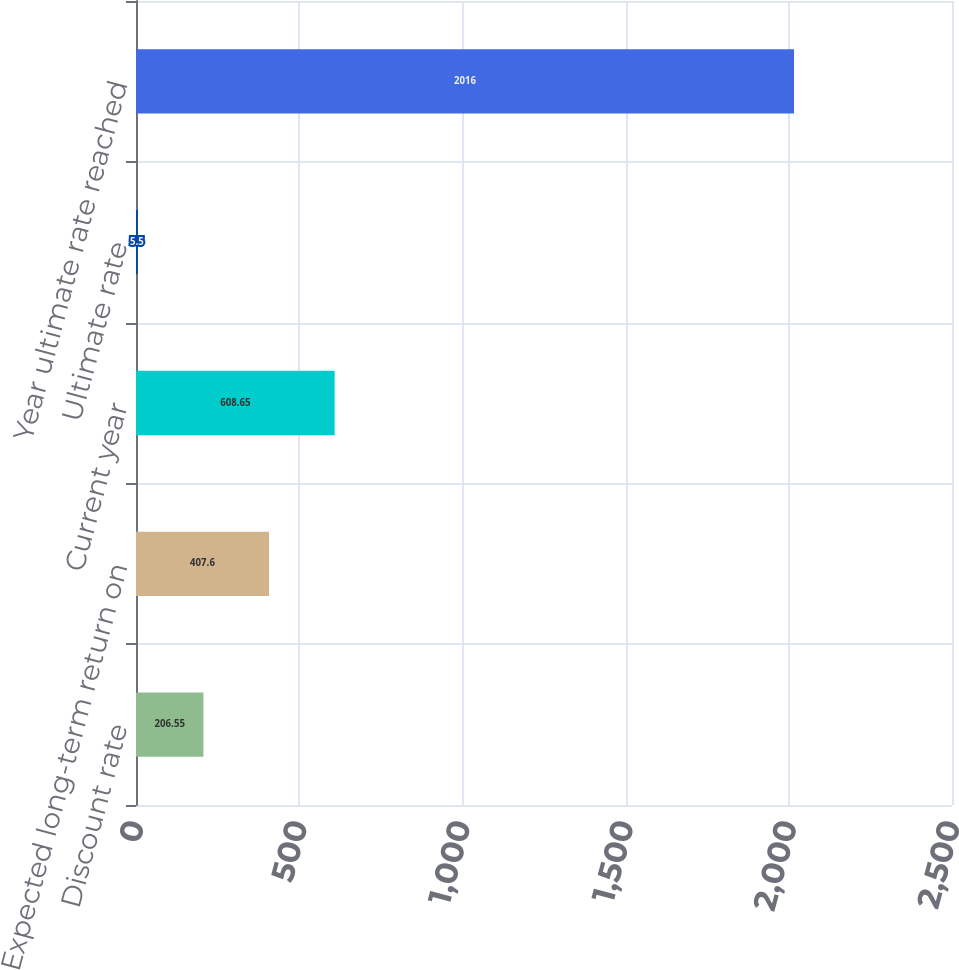Convert chart to OTSL. <chart><loc_0><loc_0><loc_500><loc_500><bar_chart><fcel>Discount rate<fcel>Expected long-term return on<fcel>Current year<fcel>Ultimate rate<fcel>Year ultimate rate reached<nl><fcel>206.55<fcel>407.6<fcel>608.65<fcel>5.5<fcel>2016<nl></chart> 